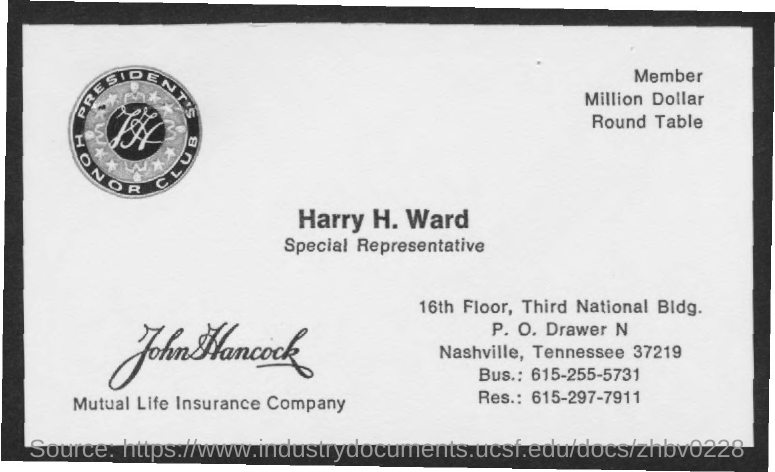What is the name of the company mentioned ?
Offer a very short reply. Mutual life insurance company. What is the bus. no. mentioned ?
Give a very brief answer. 615-255-5731. What is the res. no. mentioned ?
Your response must be concise. 615-297-7911. 